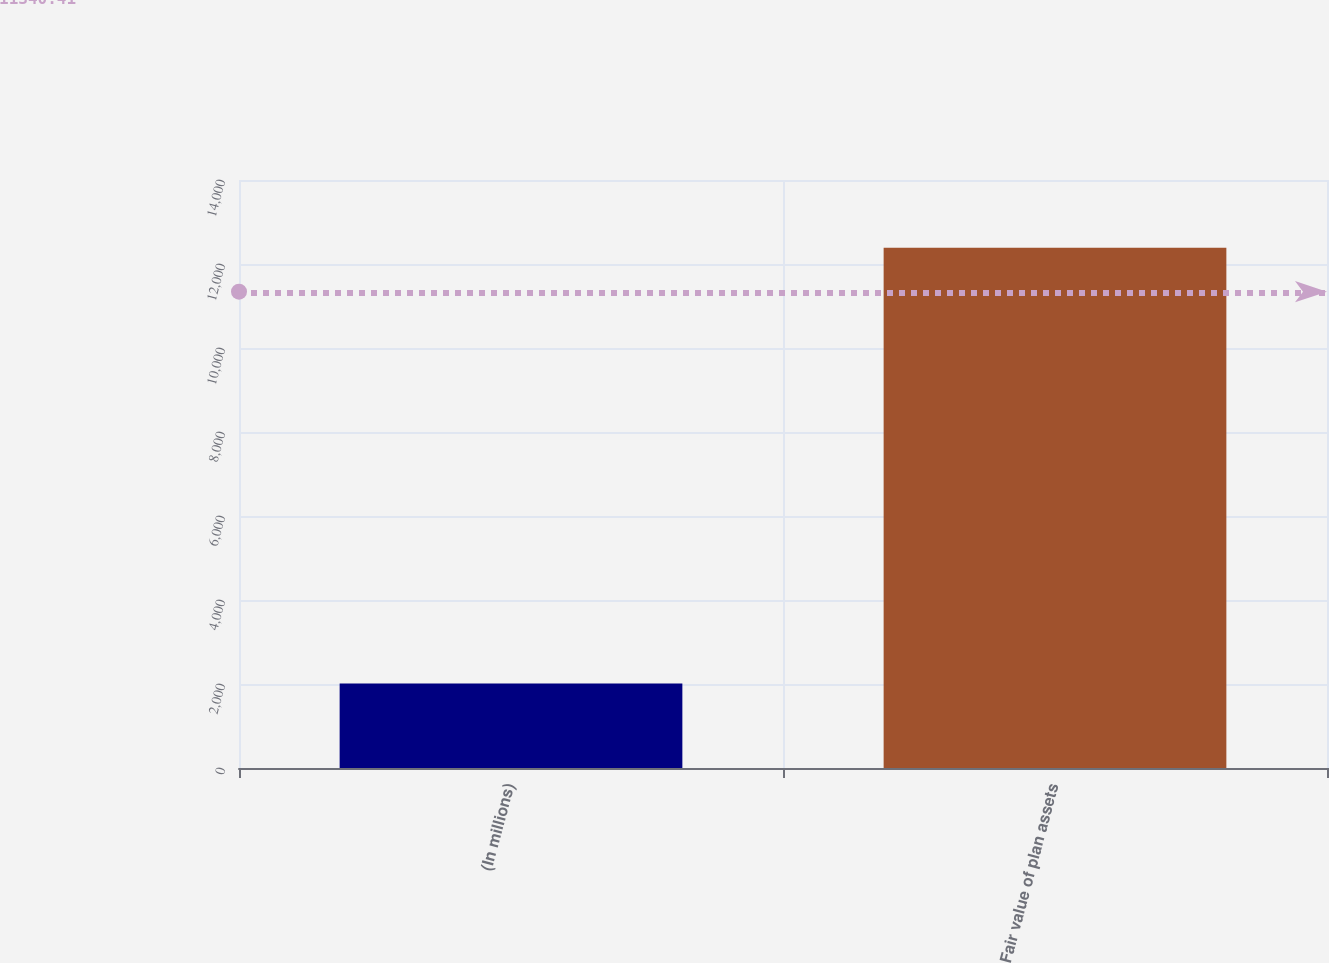Convert chart. <chart><loc_0><loc_0><loc_500><loc_500><bar_chart><fcel>(In millions)<fcel>Fair value of plan assets<nl><fcel>2014<fcel>12386<nl></chart> 